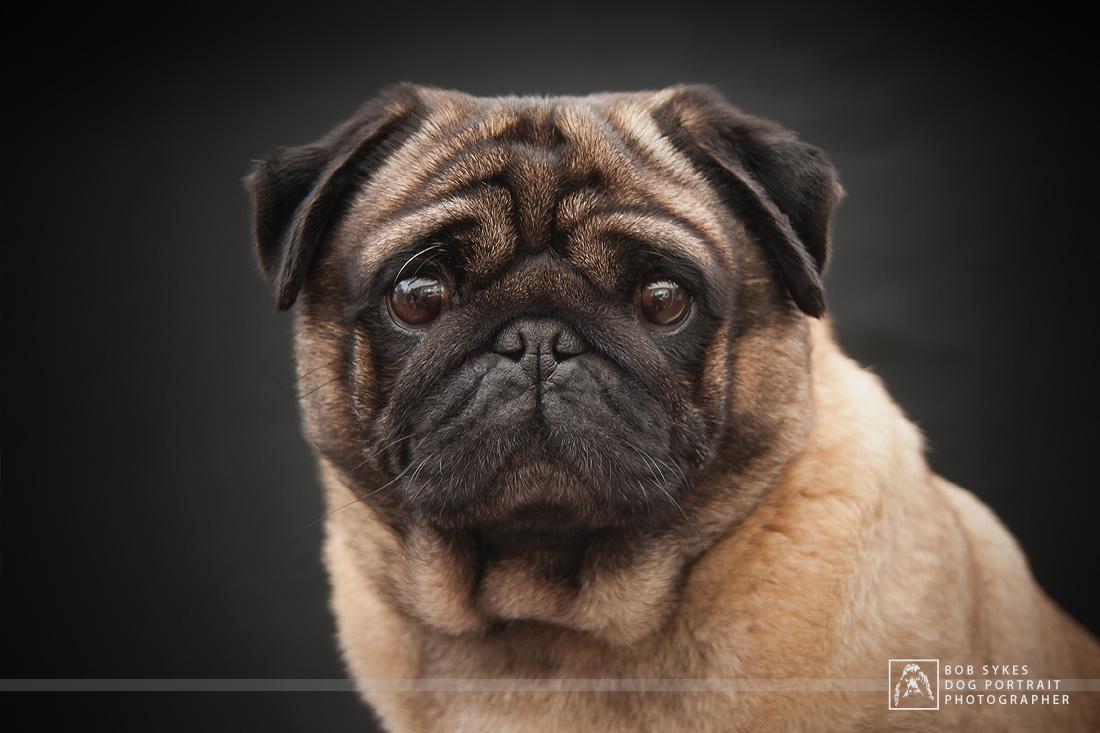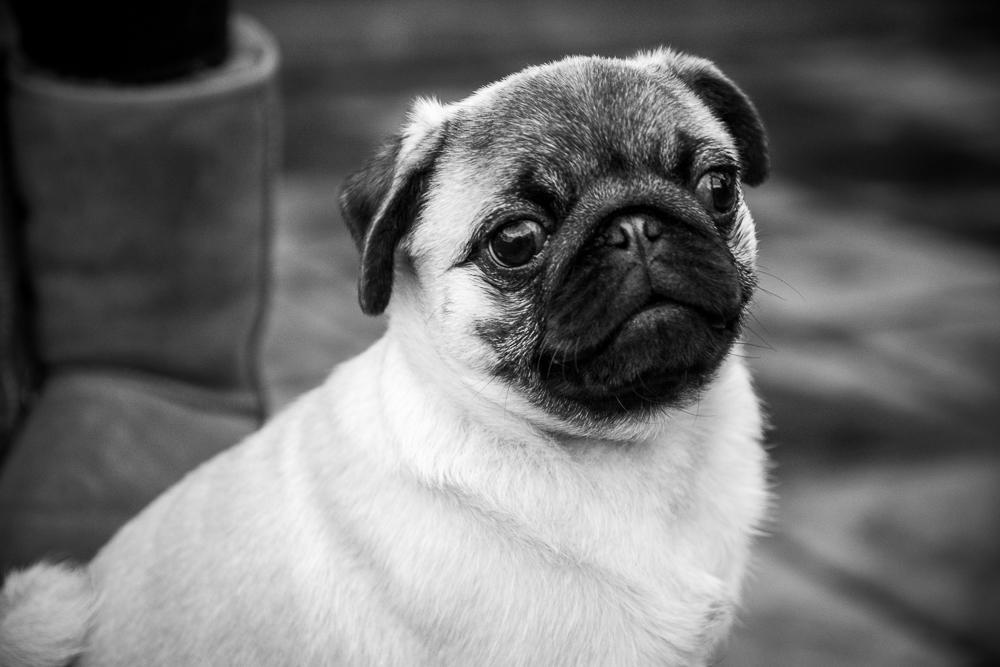The first image is the image on the left, the second image is the image on the right. Assess this claim about the two images: "At least one pug is laying down.". Correct or not? Answer yes or no. No. The first image is the image on the left, the second image is the image on the right. For the images displayed, is the sentence "There is one pug dog facing front, and at least one pug dog with its head turned slightly to the right." factually correct? Answer yes or no. Yes. 